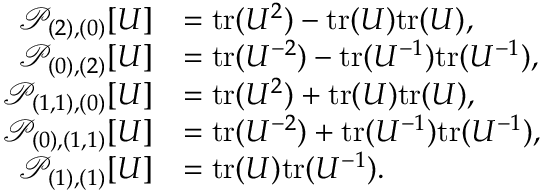<formula> <loc_0><loc_0><loc_500><loc_500>\begin{array} { r l } { \mathcal { P } _ { ( 2 ) , ( 0 ) } [ U ] } & { = t r ( U ^ { 2 } ) - t r ( U ) t r ( U ) , } \\ { \mathcal { P } _ { ( 0 ) , ( 2 ) } [ U ] } & { = t r ( U ^ { - 2 } ) - t r ( U ^ { - 1 } ) t r ( U ^ { - 1 } ) , } \\ { \mathcal { P } _ { ( 1 , 1 ) , ( 0 ) } [ U ] } & { = t r ( U ^ { 2 } ) + t r ( U ) t r ( U ) , } \\ { \mathcal { P } _ { ( 0 ) , ( 1 , 1 ) } [ U ] } & { = t r ( U ^ { - 2 } ) + t r ( U ^ { - 1 } ) t r ( U ^ { - 1 } ) , } \\ { \mathcal { P } _ { ( 1 ) , ( 1 ) } [ U ] } & { = t r ( U ) t r ( U ^ { - 1 } ) . } \end{array}</formula> 